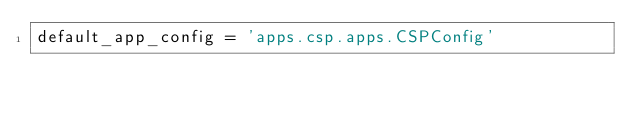<code> <loc_0><loc_0><loc_500><loc_500><_Python_>default_app_config = 'apps.csp.apps.CSPConfig'
</code> 